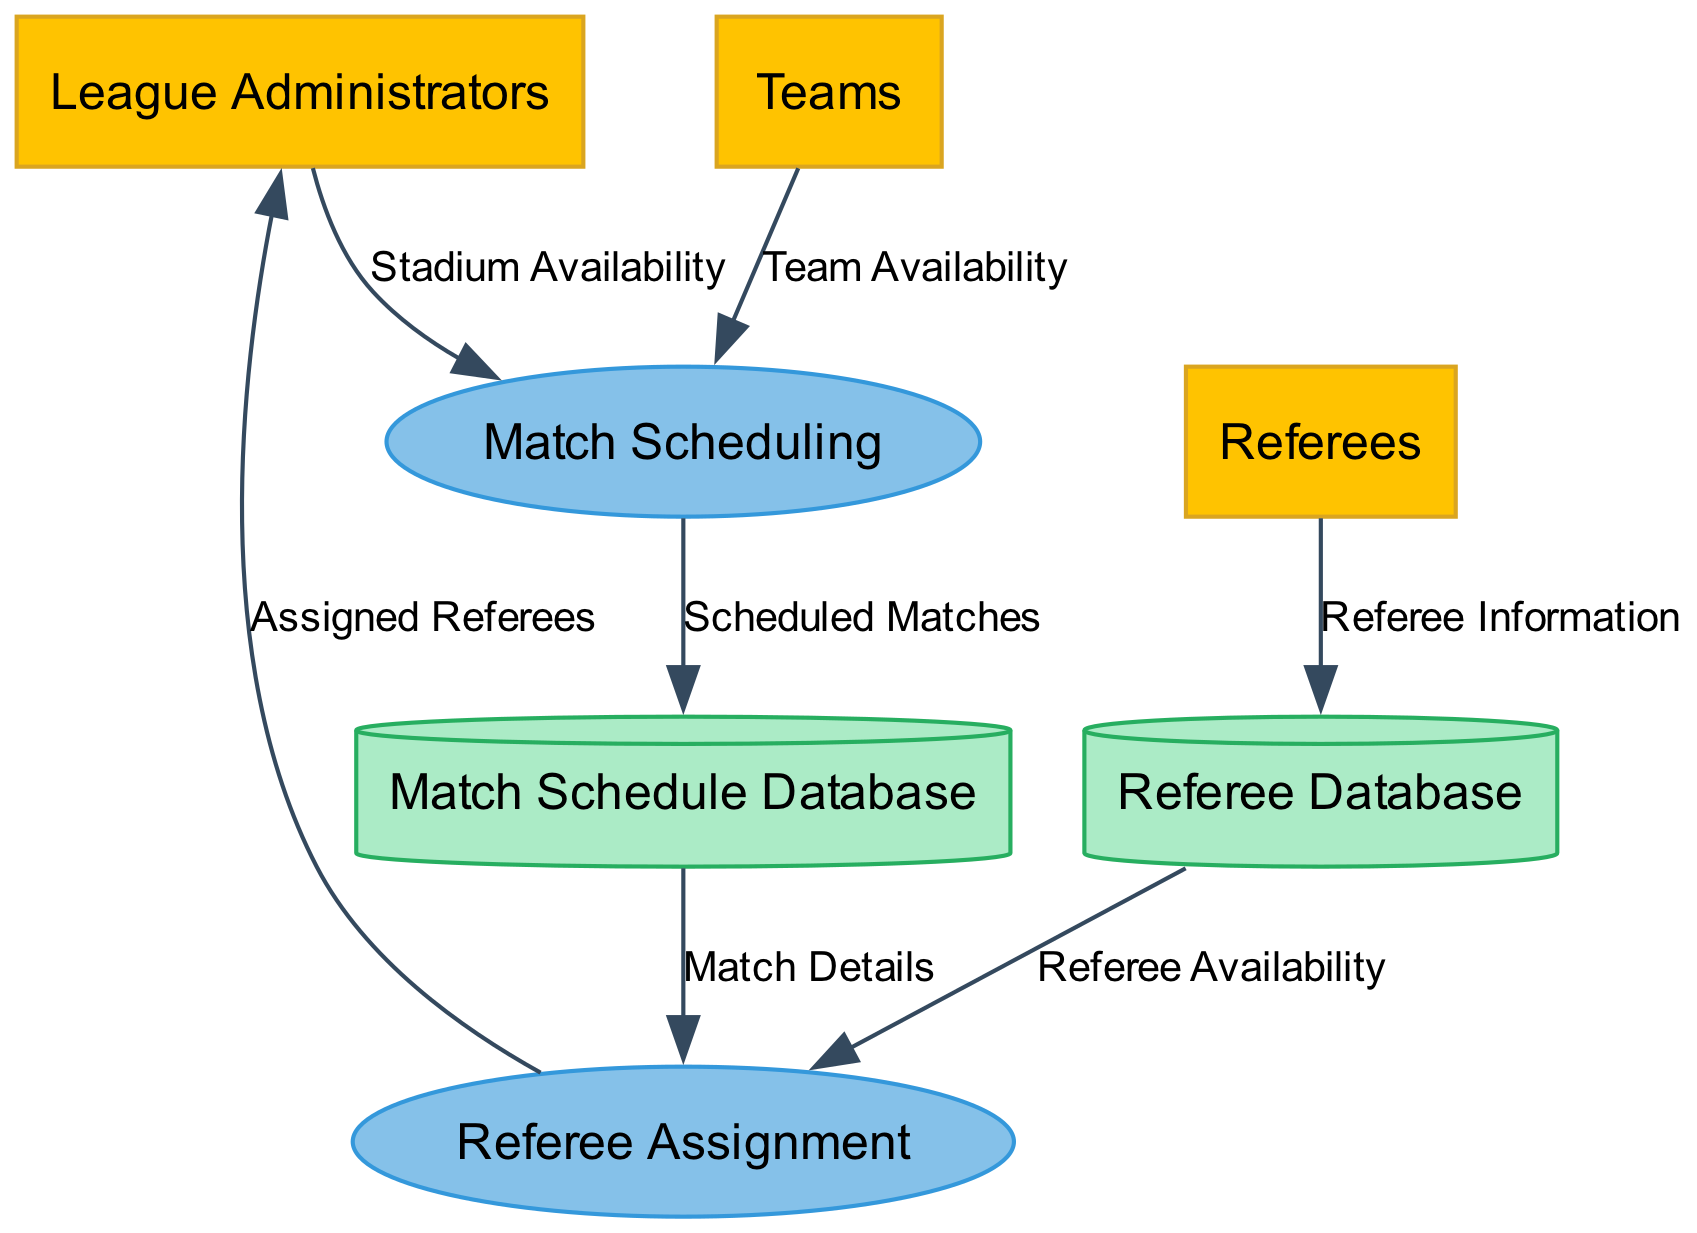What is the first process in the diagram? The first process is "Match Scheduling", which is the initial step where dates and times for all league matches are determined based on team and stadium availability.
Answer: Match Scheduling How many external entities are present in the diagram? There are three external entities: League Administrators, Referees, and Teams, each playing a distinct role in the match scheduling and referee assignment processes.
Answer: Three What outputs are generated by the "Match Scheduling" process? The "Match Scheduling" process outputs "Scheduled Matches", which are the finalized dates and times for the league matches that will be further processed for referee assignments.
Answer: Scheduled Matches Which entity provides "Stadium Availability" to the "Match Scheduling" process? The "League Administrators" provide information on stadium availability to help determine the schedule for the matches.
Answer: League Administrators What data flows from the "Match Schedule Database" to the "Referee Assignment" process? The data that flows from the "Match Schedule Database" to the "Referee Assignment" process is "Match Details", which contains information needed for assigning referees to the scheduled matches.
Answer: Match Details How does "Referee Availability" get obtained? "Referee Availability" is obtained from the "Referee Database", which contains information about all certified referees, including their availability and past assignments.
Answer: Referee Database What is stored in the "Match Schedule Database"? The "Match Schedule Database" stores "Scheduled Matches", which are the finalized match dates and times created during the match scheduling process.
Answer: Scheduled Matches Who receives the output "Assigned Referees"? The output "Assigned Referees" is sent to the "League Administrators", indicating which referees have been assigned to specific matches for oversight and management.
Answer: League Administrators What is the input for the "Referee Assignment" process? The inputs for the "Referee Assignment" process are "Referee Availability" from the Referee Database and "Scheduled Matches" from the Match Schedule Database, which together determine the appropriate referee assignments.
Answer: Referee Availability, Scheduled Matches 